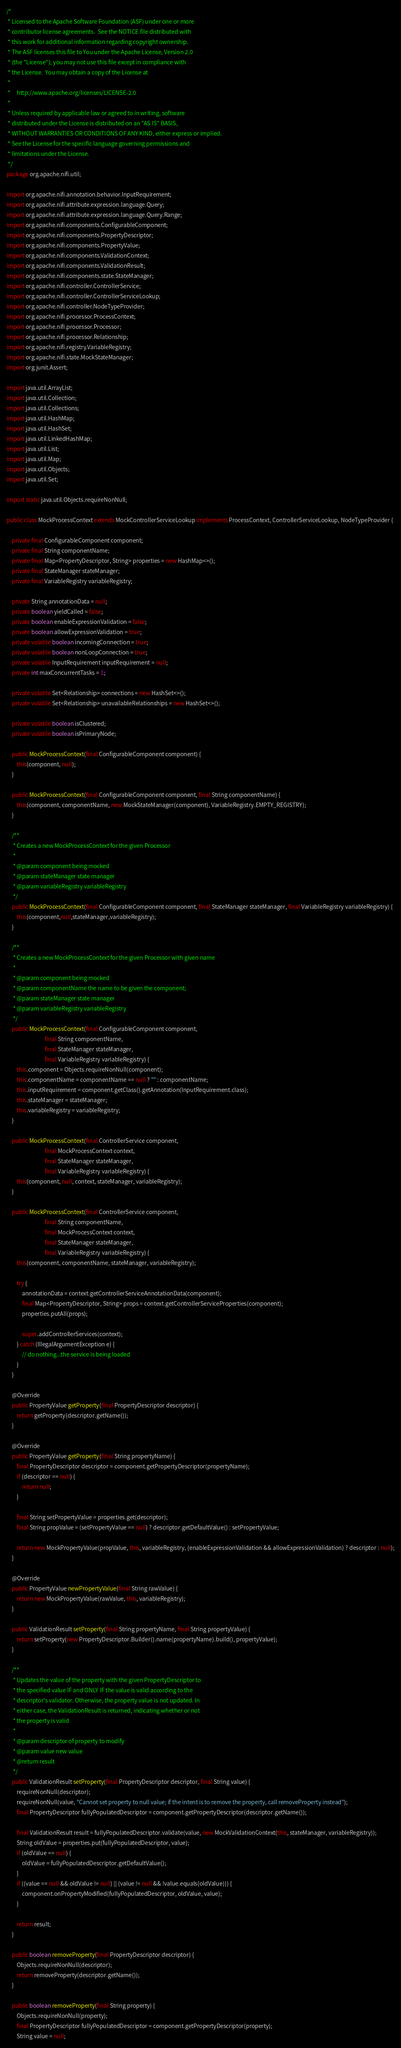Convert code to text. <code><loc_0><loc_0><loc_500><loc_500><_Java_>/*
 * Licensed to the Apache Software Foundation (ASF) under one or more
 * contributor license agreements.  See the NOTICE file distributed with
 * this work for additional information regarding copyright ownership.
 * The ASF licenses this file to You under the Apache License, Version 2.0
 * (the "License"); you may not use this file except in compliance with
 * the License.  You may obtain a copy of the License at
 *
 *     http://www.apache.org/licenses/LICENSE-2.0
 *
 * Unless required by applicable law or agreed to in writing, software
 * distributed under the License is distributed on an "AS IS" BASIS,
 * WITHOUT WARRANTIES OR CONDITIONS OF ANY KIND, either express or implied.
 * See the License for the specific language governing permissions and
 * limitations under the License.
 */
package org.apache.nifi.util;

import org.apache.nifi.annotation.behavior.InputRequirement;
import org.apache.nifi.attribute.expression.language.Query;
import org.apache.nifi.attribute.expression.language.Query.Range;
import org.apache.nifi.components.ConfigurableComponent;
import org.apache.nifi.components.PropertyDescriptor;
import org.apache.nifi.components.PropertyValue;
import org.apache.nifi.components.ValidationContext;
import org.apache.nifi.components.ValidationResult;
import org.apache.nifi.components.state.StateManager;
import org.apache.nifi.controller.ControllerService;
import org.apache.nifi.controller.ControllerServiceLookup;
import org.apache.nifi.controller.NodeTypeProvider;
import org.apache.nifi.processor.ProcessContext;
import org.apache.nifi.processor.Processor;
import org.apache.nifi.processor.Relationship;
import org.apache.nifi.registry.VariableRegistry;
import org.apache.nifi.state.MockStateManager;
import org.junit.Assert;

import java.util.ArrayList;
import java.util.Collection;
import java.util.Collections;
import java.util.HashMap;
import java.util.HashSet;
import java.util.LinkedHashMap;
import java.util.List;
import java.util.Map;
import java.util.Objects;
import java.util.Set;

import static java.util.Objects.requireNonNull;

public class MockProcessContext extends MockControllerServiceLookup implements ProcessContext, ControllerServiceLookup, NodeTypeProvider {

    private final ConfigurableComponent component;
    private final String componentName;
    private final Map<PropertyDescriptor, String> properties = new HashMap<>();
    private final StateManager stateManager;
    private final VariableRegistry variableRegistry;

    private String annotationData = null;
    private boolean yieldCalled = false;
    private boolean enableExpressionValidation = false;
    private boolean allowExpressionValidation = true;
    private volatile boolean incomingConnection = true;
    private volatile boolean nonLoopConnection = true;
    private volatile InputRequirement inputRequirement = null;
    private int maxConcurrentTasks = 1;

    private volatile Set<Relationship> connections = new HashSet<>();
    private volatile Set<Relationship> unavailableRelationships = new HashSet<>();

    private volatile boolean isClustered;
    private volatile boolean isPrimaryNode;

    public MockProcessContext(final ConfigurableComponent component) {
        this(component, null);
    }

    public MockProcessContext(final ConfigurableComponent component, final String componentName) {
        this(component, componentName, new MockStateManager(component), VariableRegistry.EMPTY_REGISTRY);
    }

    /**
     * Creates a new MockProcessContext for the given Processor
     *
     * @param component being mocked
     * @param stateManager state manager
     * @param variableRegistry variableRegistry
     */
    public MockProcessContext(final ConfigurableComponent component, final StateManager stateManager, final VariableRegistry variableRegistry) {
        this(component,null,stateManager,variableRegistry);
    }

    /**
     * Creates a new MockProcessContext for the given Processor with given name
     *
     * @param component being mocked
     * @param componentName the name to be given the component;
     * @param stateManager state manager
     * @param variableRegistry variableRegistry
     */
    public MockProcessContext(final ConfigurableComponent component,
                              final String componentName,
                              final StateManager stateManager,
                              final VariableRegistry variableRegistry) {
        this.component = Objects.requireNonNull(component);
        this.componentName = componentName == null ? "" : componentName;
        this.inputRequirement = component.getClass().getAnnotation(InputRequirement.class);
        this.stateManager = stateManager;
        this.variableRegistry = variableRegistry;
    }

    public MockProcessContext(final ControllerService component,
                              final MockProcessContext context,
                              final StateManager stateManager,
                              final VariableRegistry variableRegistry) {
        this(component, null, context, stateManager, variableRegistry);
    }

    public MockProcessContext(final ControllerService component,
                              final String componentName,
                              final MockProcessContext context,
                              final StateManager stateManager,
                              final VariableRegistry variableRegistry) {
        this(component, componentName, stateManager, variableRegistry);

        try {
            annotationData = context.getControllerServiceAnnotationData(component);
            final Map<PropertyDescriptor, String> props = context.getControllerServiceProperties(component);
            properties.putAll(props);

            super.addControllerServices(context);
        } catch (IllegalArgumentException e) {
            // do nothing...the service is being loaded
        }
    }

    @Override
    public PropertyValue getProperty(final PropertyDescriptor descriptor) {
        return getProperty(descriptor.getName());
    }

    @Override
    public PropertyValue getProperty(final String propertyName) {
        final PropertyDescriptor descriptor = component.getPropertyDescriptor(propertyName);
        if (descriptor == null) {
            return null;
        }

        final String setPropertyValue = properties.get(descriptor);
        final String propValue = (setPropertyValue == null) ? descriptor.getDefaultValue() : setPropertyValue;

        return new MockPropertyValue(propValue, this, variableRegistry, (enableExpressionValidation && allowExpressionValidation) ? descriptor : null);
    }

    @Override
    public PropertyValue newPropertyValue(final String rawValue) {
        return new MockPropertyValue(rawValue, this, variableRegistry);
    }

    public ValidationResult setProperty(final String propertyName, final String propertyValue) {
        return setProperty(new PropertyDescriptor.Builder().name(propertyName).build(), propertyValue);
    }

    /**
     * Updates the value of the property with the given PropertyDescriptor to
     * the specified value IF and ONLY IF the value is valid according to the
     * descriptor's validator. Otherwise, the property value is not updated. In
     * either case, the ValidationResult is returned, indicating whether or not
     * the property is valid
     *
     * @param descriptor of property to modify
     * @param value new value
     * @return result
     */
    public ValidationResult setProperty(final PropertyDescriptor descriptor, final String value) {
        requireNonNull(descriptor);
        requireNonNull(value, "Cannot set property to null value; if the intent is to remove the property, call removeProperty instead");
        final PropertyDescriptor fullyPopulatedDescriptor = component.getPropertyDescriptor(descriptor.getName());

        final ValidationResult result = fullyPopulatedDescriptor.validate(value, new MockValidationContext(this, stateManager, variableRegistry));
        String oldValue = properties.put(fullyPopulatedDescriptor, value);
        if (oldValue == null) {
            oldValue = fullyPopulatedDescriptor.getDefaultValue();
        }
        if ((value == null && oldValue != null) || (value != null && !value.equals(oldValue))) {
            component.onPropertyModified(fullyPopulatedDescriptor, oldValue, value);
        }

        return result;
    }

    public boolean removeProperty(final PropertyDescriptor descriptor) {
        Objects.requireNonNull(descriptor);
        return removeProperty(descriptor.getName());
    }

    public boolean removeProperty(final String property) {
        Objects.requireNonNull(property);
        final PropertyDescriptor fullyPopulatedDescriptor = component.getPropertyDescriptor(property);
        String value = null;
</code> 